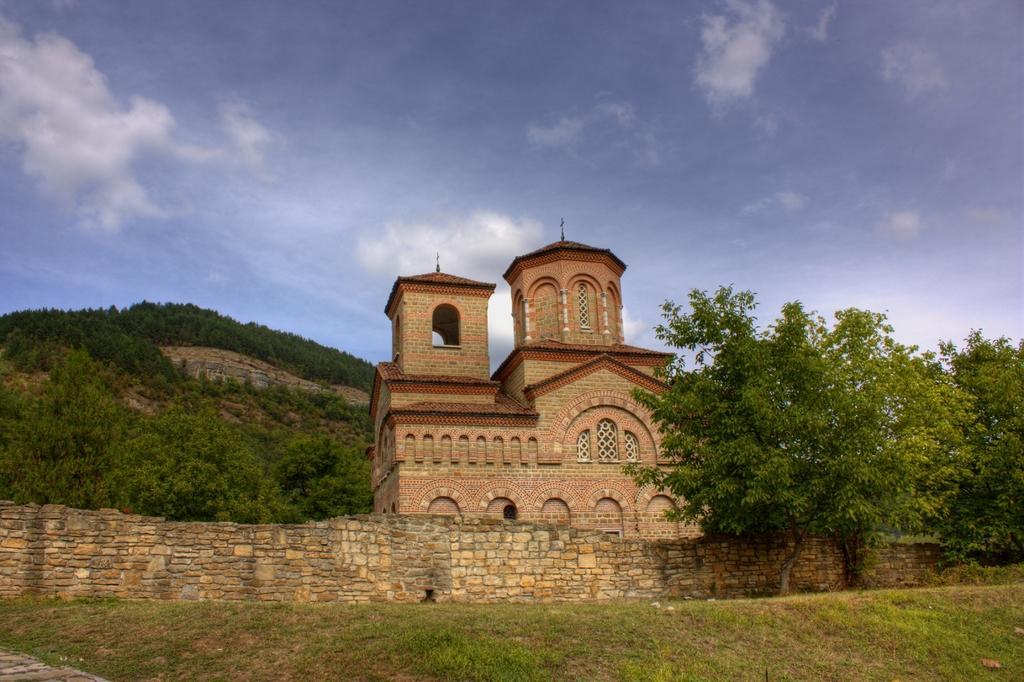In one or two sentences, can you explain what this image depicts? In this picture I can observe a monument. In front of this monument I can observe a stone wall. I can observe trees and plants on the ground. In the background there are some clouds in the sky. 